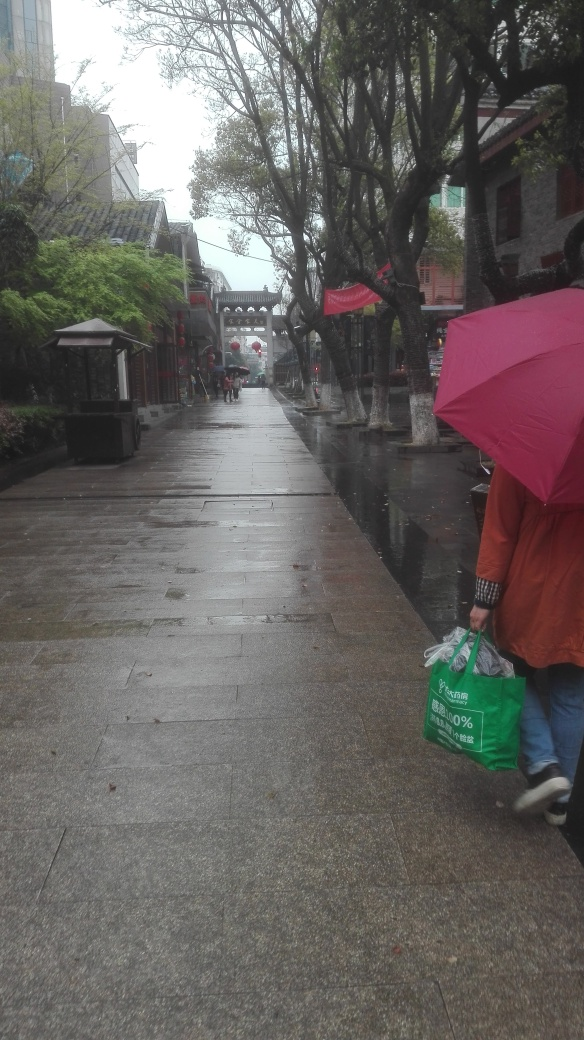Is the overall clarity of the image good? While the image is discernible and the main elements can be identified, the clarity could be improved. Factors such as the overcast weather, the presence of rain, and the camera's exposure settings, have contributed to a slightly blurred effect, particularly in the distant background. Adjusting the focus or capturing the scene in better lighting conditions could enhance the overall sharpness of the image. 